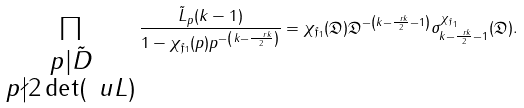<formula> <loc_0><loc_0><loc_500><loc_500>\prod _ { \substack { p | \tilde { D } \\ p \nmid 2 \det ( \ u L ) } } \frac { \tilde { L } _ { p } ( k - 1 ) } { 1 - \chi _ { \mathfrak { f } _ { 1 } } ( p ) p ^ { - \left ( k - \frac { \ r k } { 2 } \right ) } } & = \chi _ { \mathfrak { f } _ { 1 } } ( \mathfrak { D } ) \mathfrak { D } ^ { - \left ( k - \frac { \ r k } { 2 } - 1 \right ) } \sigma _ { k - \frac { \ r k } { 2 } - 1 } ^ { \chi _ { \mathfrak { f } _ { 1 } } } ( \mathfrak { D } ) .</formula> 